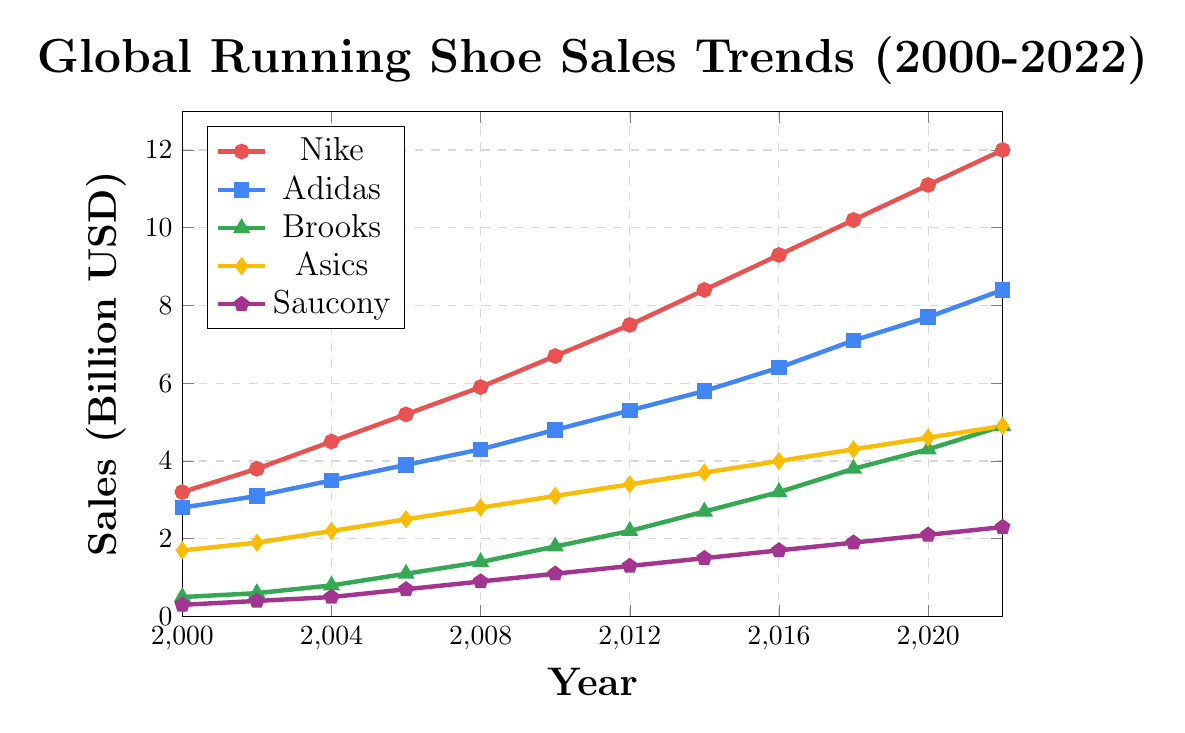What is the overall trend for Nike's sales from 2000 to 2022? Nike's sales have increased steadily from 3.2 billion USD in 2000 to 12.0 billion USD in 2022.
Answer: Increasing In which year did Adidas's sales surpass 5 billion USD for the first time? By examining the trend for Adidas, we see that the sales reached 5.3 billion USD in 2012, surpassing 5 billion USD for the first time.
Answer: 2012 How much did Brooks' sales increase from 2010 to 2022? In 2010, Brooks' sales were 1.8 billion USD, and in 2022, they were 4.9 billion USD. The increase can be calculated as 4.9 - 1.8 = 3.1 billion USD.
Answer: 3.1 billion USD Which brand had the highest sales in 2022 and what are the sales figures? By referring to the sales figures for 2022, Nike had the highest sales at 12.0 billion USD.
Answer: Nike, 12.0 billion USD Compare the sales trends of Asics and Saucony from 2000 to 2022. Both Asics and Saucony show an increasing trend. Asics' sales grew from 1.7 to 4.9 billion USD, while Saucony's sales grew from 0.3 to 2.3 billion USD over the same period. Asics had consistently higher sales than Saucony.
Answer: Asics had higher sales; both increased In which year did Brooks' sales surpass 3 billion USD and how does this compare to Saucony's sales in the same year? Brooks' sales surpassed 3 billion USD in 2016 with 3.2 billion USD, whereas Saucony's sales in the same year were 1.7 billion USD.
Answer: 2016; Brooks: 3.2 billion USD, Saucony: 1.7 billion USD What's the average annual sales figure for Nike over the given period? The sales figures for Nike are: 3.2, 3.8, 4.5, 5.2, 5.9, 6.7, 7.5, 8.4, 9.3, 10.2, 11.1, 12.0. The average is calculated as (3.2 + 3.8 + 4.5 + 5.2 + 5.9 + 6.7 + 7.5 + 8.4 + 9.3 + 10.2 + 11.1 + 12.0) / 12 = 7.45 billion USD.
Answer: 7.45 billion USD By how much did Adidas's sales increase from 2004 to 2014? In 2004, Adidas's sales were 3.5 billion USD and in 2014, they were 5.8 billion USD. The increase is 5.8 - 3.5 = 2.3 billion USD.
Answer: 2.3 billion USD 